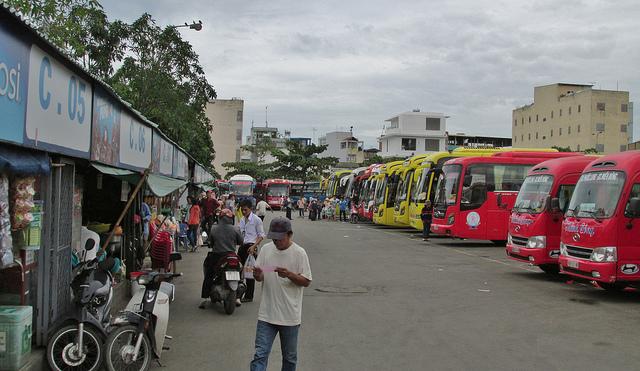How many vehicles are in the picture?
Give a very brief answer. 12. What color are the 3 front buses?
Give a very brief answer. Red. How many yellow buses are there?
Write a very short answer. 3. How many motorbikes are there?
Concise answer only. 3. Is the man's white shirt tucked in?
Write a very short answer. No. Who is in camo?
Be succinct. No one. What does this stall sell?
Give a very brief answer. Food. Is this an airport?
Be succinct. No. What color are the persons pants?
Be succinct. Blue. How many motorcycles are there?
Short answer required. 3. Are these bikes motorcycles?
Short answer required. Yes. What color is the van?
Be succinct. Red. What color is the city bus?
Short answer required. Red. Are these people in a hurry?
Keep it brief. No. What part of town is this in?
Answer briefly. Downtown. 